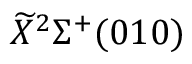Convert formula to latex. <formula><loc_0><loc_0><loc_500><loc_500>\widetilde { X ^ { 2 } \Sigma ^ { + } ( 0 1 0 )</formula> 